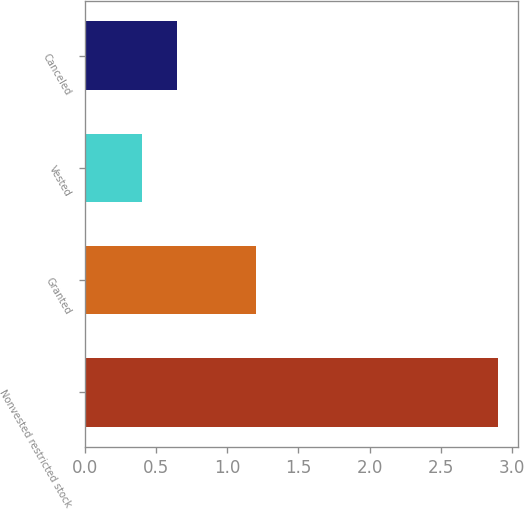<chart> <loc_0><loc_0><loc_500><loc_500><bar_chart><fcel>Nonvested restricted stock<fcel>Granted<fcel>Vested<fcel>Canceled<nl><fcel>2.9<fcel>1.2<fcel>0.4<fcel>0.65<nl></chart> 